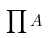<formula> <loc_0><loc_0><loc_500><loc_500>\prod A</formula> 